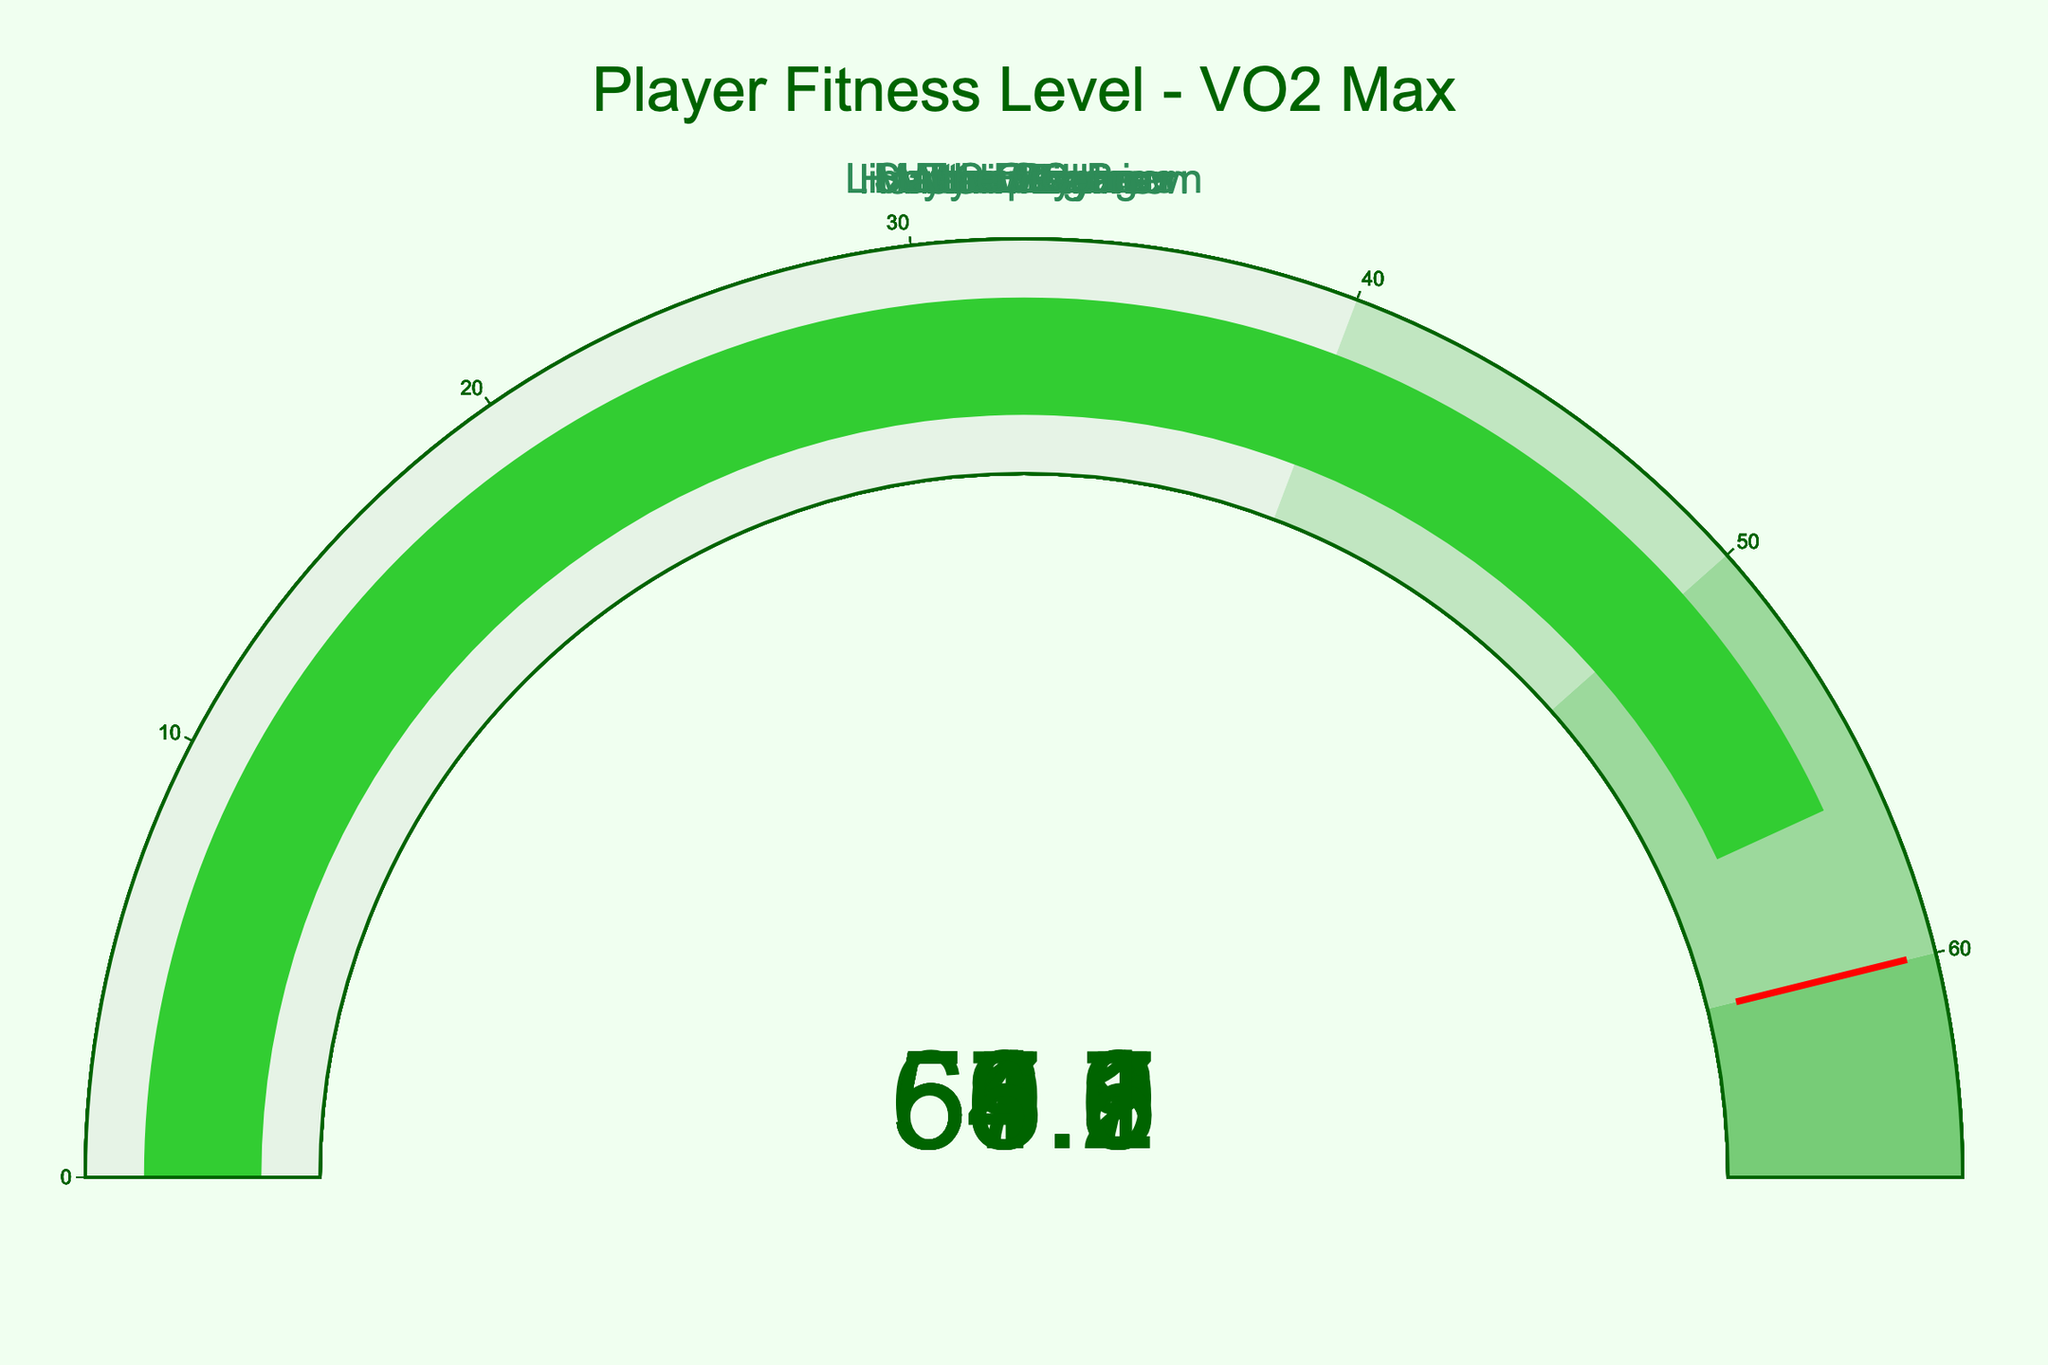What is the title of the figure? The title is typically displayed at the top of the figure, summarizing the content. In this gauge chart, it reads **"Player Fitness Level - VO2 Max"** based on the description.
Answer: Player Fitness Level - VO2 Max What is the VO2 Max for Myer Bevan? To find the VO2 Max for Myer Bevan, look for the gauge with his name and note the displayed number.
Answer: 61.5 How many players exceed the threshold value of 60? Identify which gauges have a VO2 Max value greater than 60. According to the provided VO2 Max values, only Myer Bevan exceeds this threshold.
Answer: 1 What color represents the highest VO2 Max value range in the gauges? The provided steps indicate color coding for value ranges, with the highest range (60-65) being represented by the color **#77CC77** (a shade of green).
Answer: Green Which player has the lowest VO2 Max value? Compare all the VO2 Max values and identify the player with the smallest number, which is Hannah Wilkinson with 53.9.
Answer: Hannah Wilkinson What is the average VO2 Max of all players? Sum all VO2 Max values (58.2 + 55.7 + 61.5 + 53.9 + 57.3 + 59.8 + 54.6 + 56.1 = 457.1) and divide by the number of players (8). The calculation gives an average of 457.1 / 8 = 57.1375.
Answer: 57.1 Is there any VO2 Max value equal to the threshold value of 60? Check all gauges for a displayed number exactly equal to 60. There is no such value among the given data.
Answer: No Compare the VO2 Max of Marvin Eakins and Libby Copus-Brown. Who has a higher value? Compare Marvin Eakins (59.8) and Libby Copus-Brown (54.6), and note that Marvin Eakins has the higher value.
Answer: Marvin Eakins What is the range of the VO2 Max values in the figure? Determine the difference between the highest and lowest VO2 Max values, with the highest being Myer Bevan (61.5) and the lowest being Hannah Wilkinson (53.9). The range is 61.5 - 53.9 = 7.6.
Answer: 7.6 Which players fall in the 50-60 VO2 Max range? Identify players with VO2 Max values between 50 and 60. These are Tom Stayte (58.2), Sarah Gregorius (55.7), Atta Elayyan (57.3), Marvin Eakins (59.8), Matthew Conger (56.1), and Libby Copus-Brown (54.6).
Answer: Tom Stayte, Sarah Gregorius, Atta Elayyan, Marvin Eakins, Matthew Conger, Libby Copus-Brown 